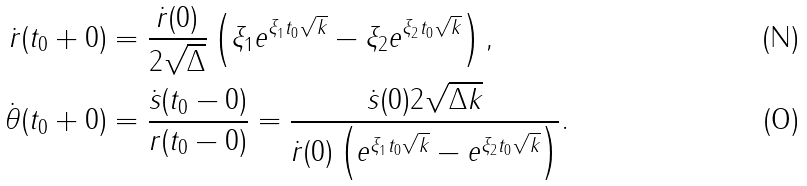<formula> <loc_0><loc_0><loc_500><loc_500>\dot { r } ( t _ { 0 } + 0 ) & = \frac { \dot { r } ( 0 ) } { 2 \sqrt { \Delta } } \left ( \xi _ { 1 } e ^ { \xi _ { 1 } t _ { 0 } \sqrt { k } } - \xi _ { 2 } e ^ { \xi _ { 2 } t _ { 0 } \sqrt { k } } \right ) , \\ \dot { \theta } ( t _ { 0 } + 0 ) & = \frac { \dot { s } ( t _ { 0 } - 0 ) } { r ( t _ { 0 } - 0 ) } = \frac { \dot { s } ( 0 ) 2 \sqrt { \Delta k } } { \dot { r } ( 0 ) \left ( e ^ { \xi _ { 1 } t _ { 0 } \sqrt { k } } - e ^ { \xi _ { 2 } t _ { 0 } \sqrt { k } } \right ) } .</formula> 